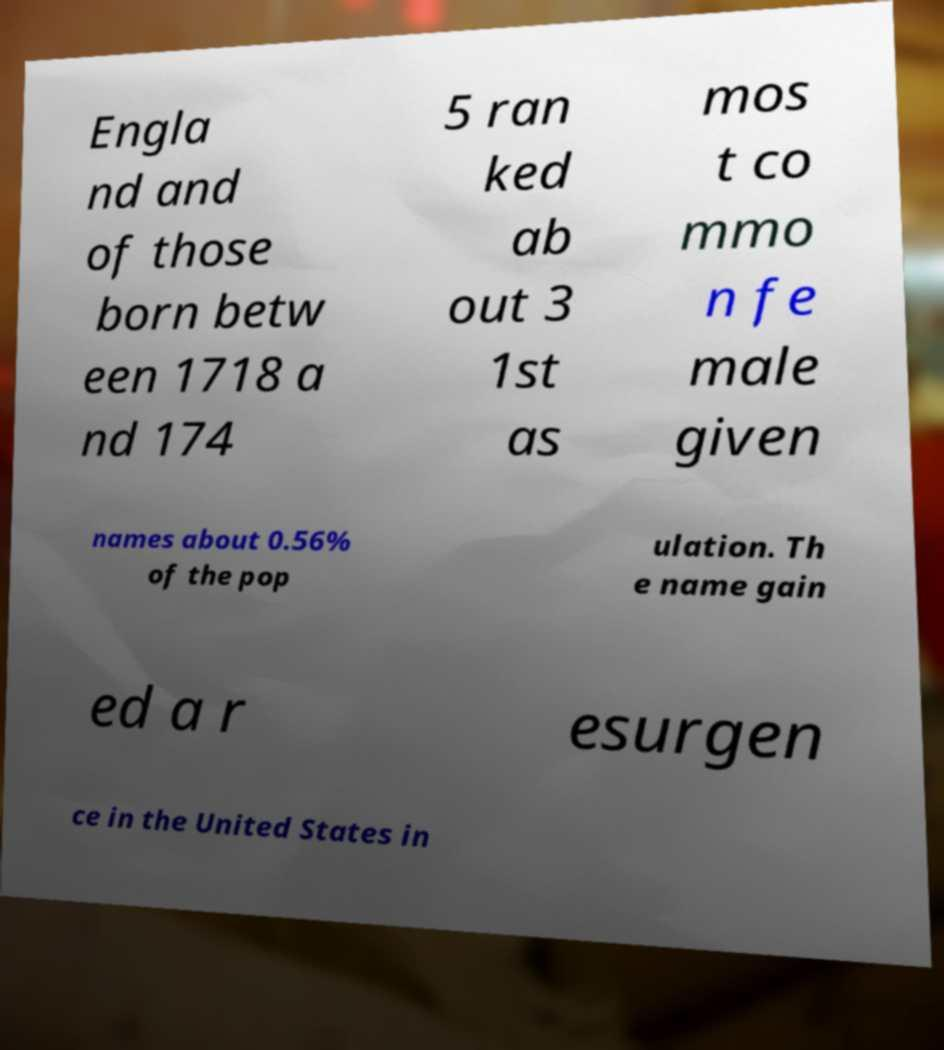Can you accurately transcribe the text from the provided image for me? Engla nd and of those born betw een 1718 a nd 174 5 ran ked ab out 3 1st as mos t co mmo n fe male given names about 0.56% of the pop ulation. Th e name gain ed a r esurgen ce in the United States in 